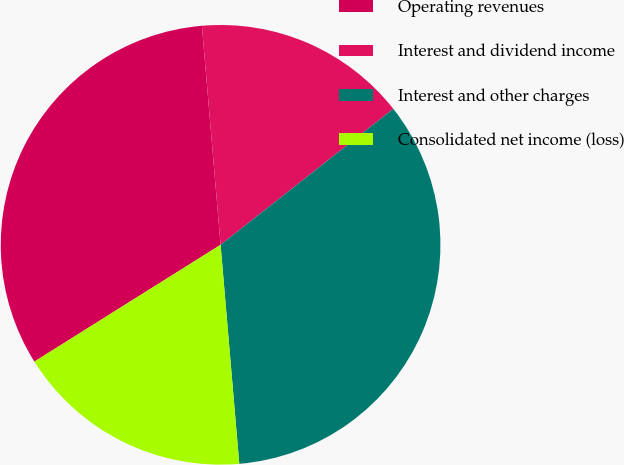Convert chart to OTSL. <chart><loc_0><loc_0><loc_500><loc_500><pie_chart><fcel>Operating revenues<fcel>Interest and dividend income<fcel>Interest and other charges<fcel>Consolidated net income (loss)<nl><fcel>32.56%<fcel>15.74%<fcel>34.26%<fcel>17.44%<nl></chart> 